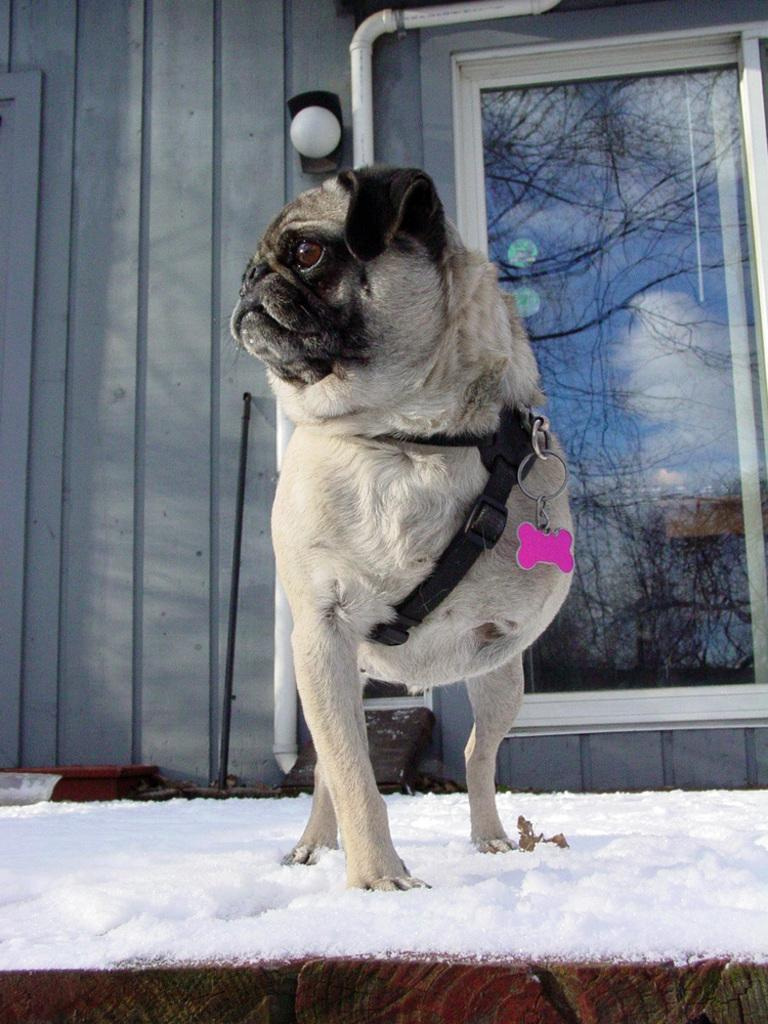What animal can be seen in the image? There is a dog in the image. What is the dog wearing? The dog is wearing a belt. What type of terrain is the dog standing on? The dog is standing on snow. What can be seen in the background of the image? There is a wall and a window in the background of the image. What is reflected in the window? The sky with clouds is reflected in the window. What type of coal is the dog carrying in a bucket in the image? There is no coal or bucket present in the image. What type of cap is the dog wearing in the image? The dog is not wearing a cap in the image; it is wearing a belt. 